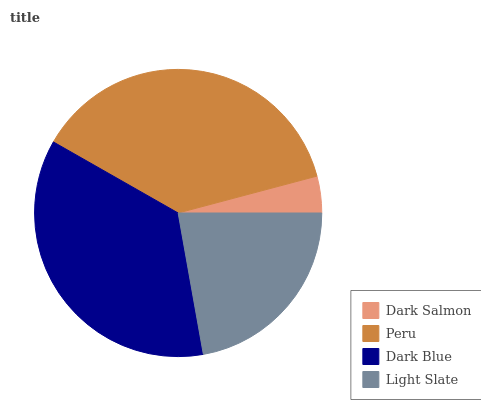Is Dark Salmon the minimum?
Answer yes or no. Yes. Is Peru the maximum?
Answer yes or no. Yes. Is Dark Blue the minimum?
Answer yes or no. No. Is Dark Blue the maximum?
Answer yes or no. No. Is Peru greater than Dark Blue?
Answer yes or no. Yes. Is Dark Blue less than Peru?
Answer yes or no. Yes. Is Dark Blue greater than Peru?
Answer yes or no. No. Is Peru less than Dark Blue?
Answer yes or no. No. Is Dark Blue the high median?
Answer yes or no. Yes. Is Light Slate the low median?
Answer yes or no. Yes. Is Dark Salmon the high median?
Answer yes or no. No. Is Dark Salmon the low median?
Answer yes or no. No. 